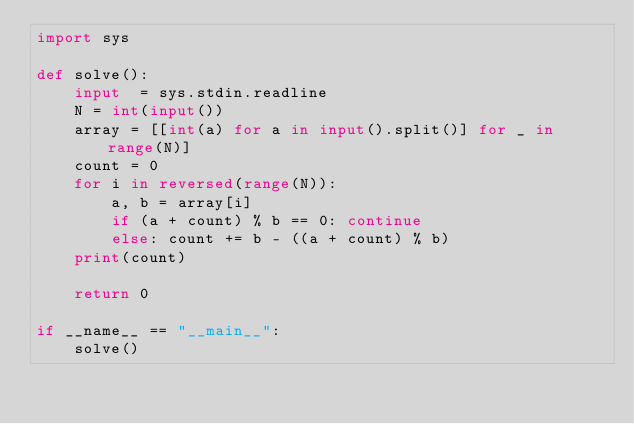Convert code to text. <code><loc_0><loc_0><loc_500><loc_500><_Python_>import sys

def solve():
    input  = sys.stdin.readline
    N = int(input())
    array = [[int(a) for a in input().split()] for _ in range(N)]
    count = 0
    for i in reversed(range(N)):
        a, b = array[i]
        if (a + count) % b == 0: continue
        else: count += b - ((a + count) % b)
    print(count)

    return 0

if __name__ == "__main__":
    solve()</code> 